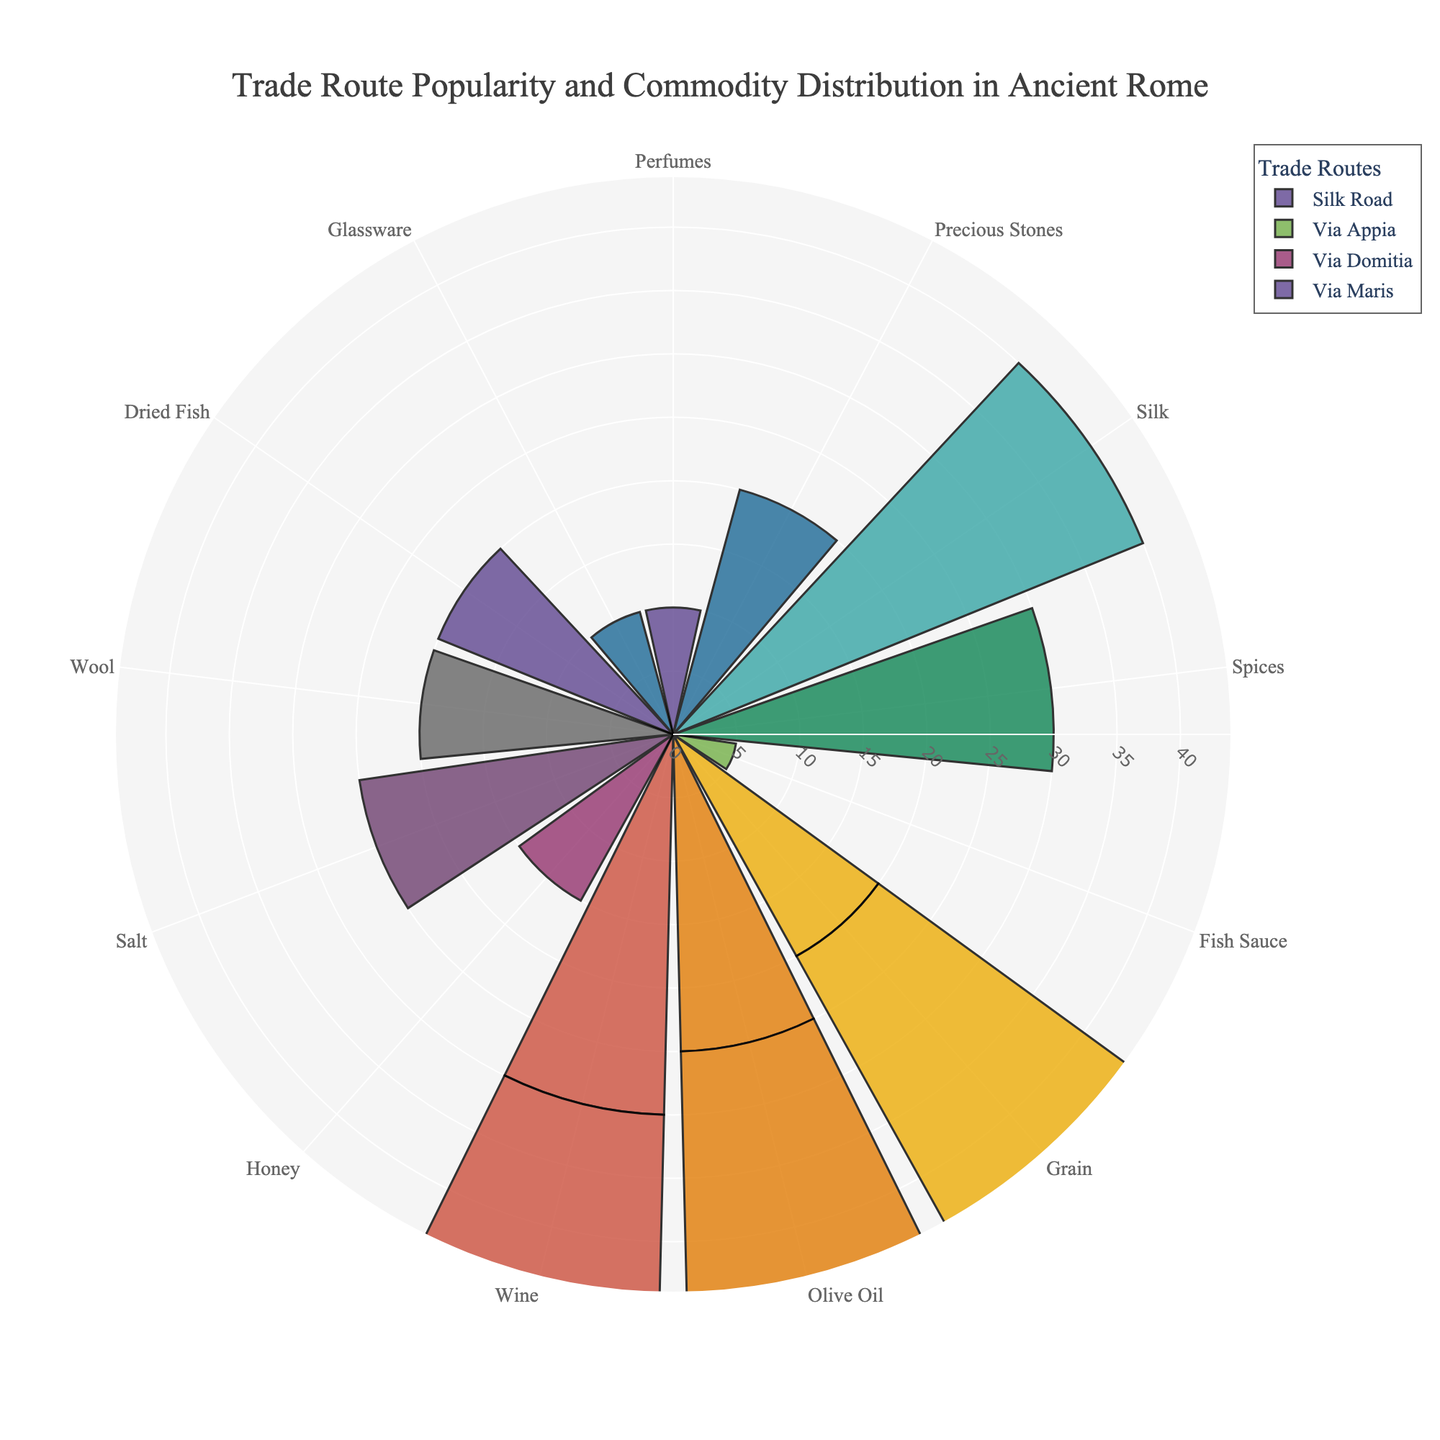Which trade route has the highest total popularity? By summing up the popularity values for each trade route: Via Appia = 30 + 25 + 20 + 5 = 80, Silk Road = 40 + 30 + 20 + 10 = 100, Via Domitia = 35 + 25 + 20 + 15 = 95, and Via Maris = 40 + 30 + 20 + 10 = 100, we find that both the Silk Road and Via Maris have the highest total popularity with a value of 100.
Answer: Silk Road and Via Maris Which commodity has the highest popularity on the Via Appia? By checking the individual popularity values on the Via Appia route: Wine = 30, Olive Oil = 25, Grain = 20, Fish Sauce = 5, we find that Wine has the highest popularity.
Answer: Wine Comparing the Silk Road and Via Domitia, which route is more popular for Wine? The Silk Road does not include Wine in its commodities. Therefore, we consider the Via Domitia where Wine has a popularity of 35. Hence, Via Domitia is more popular for Wine.
Answer: Via Domitia Which commodity is exclusively found in the Silk Road route and not in any other routes? By comparing the commodities across all routes, exclusively located in the Silk Road and absent in others are Silk, Spices, Precious Stones, and Perfumes. Upon further scrutiny, Silk stands out as the most notable exclusive commodity.
Answer: Silk What is the average popularity of Olive Oil across all trade routes? Adding the popularity values for Olive Oil across the Via Appia (25) and Via Maris (30) and dividing by 2 gives the average: (25 + 30)/2 = 27.5.
Answer: 27.5 Which trade route carries both Grain and Olive Oil and how popular are they combined? Checking the routes, Via Appia and Via Maris both carry Grain and Olive Oil. For Via Appia, the combined popularity is 20 (Grain) + 25 (Olive Oil) = 45. For Via Maris, the combined popularity is 40 (Grain) + 30 (Olive Oil) = 70. Hence, Via Maris has a combined popularity of Grain and Olive Oil of 70.
Answer: Via Maris, 70 What is the least popular commodity on Via Maris, and what is its popularity? The commodities on Via Maris are Grain (40), Olive Oil (30), Dried Fish (20), and Glassware (10). Glassware is the least popular with a popularity score of 10.
Answer: Glassware, 10 